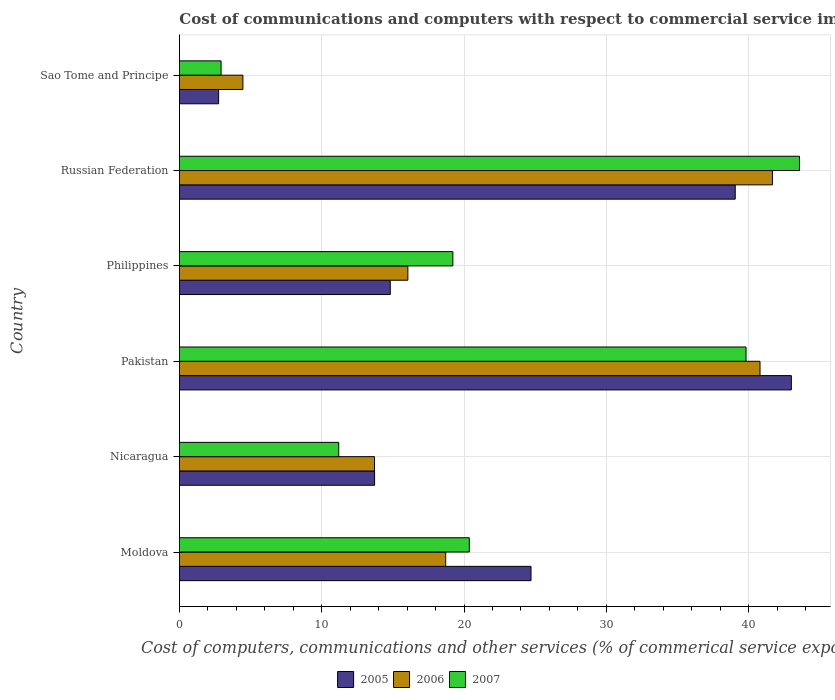How many different coloured bars are there?
Offer a very short reply. 3. Are the number of bars on each tick of the Y-axis equal?
Keep it short and to the point. Yes. How many bars are there on the 4th tick from the top?
Keep it short and to the point. 3. How many bars are there on the 2nd tick from the bottom?
Provide a short and direct response. 3. What is the label of the 3rd group of bars from the top?
Offer a terse response. Philippines. What is the cost of communications and computers in 2007 in Russian Federation?
Your answer should be very brief. 43.57. Across all countries, what is the maximum cost of communications and computers in 2007?
Give a very brief answer. 43.57. Across all countries, what is the minimum cost of communications and computers in 2005?
Provide a short and direct response. 2.76. In which country was the cost of communications and computers in 2005 minimum?
Your answer should be compact. Sao Tome and Principe. What is the total cost of communications and computers in 2006 in the graph?
Your response must be concise. 135.41. What is the difference between the cost of communications and computers in 2007 in Nicaragua and that in Russian Federation?
Your answer should be compact. -32.38. What is the difference between the cost of communications and computers in 2007 in Russian Federation and the cost of communications and computers in 2005 in Sao Tome and Principe?
Ensure brevity in your answer.  40.82. What is the average cost of communications and computers in 2005 per country?
Your response must be concise. 23.01. What is the difference between the cost of communications and computers in 2006 and cost of communications and computers in 2005 in Philippines?
Provide a short and direct response. 1.24. What is the ratio of the cost of communications and computers in 2005 in Moldova to that in Philippines?
Make the answer very short. 1.67. Is the difference between the cost of communications and computers in 2006 in Nicaragua and Pakistan greater than the difference between the cost of communications and computers in 2005 in Nicaragua and Pakistan?
Provide a succinct answer. Yes. What is the difference between the highest and the second highest cost of communications and computers in 2006?
Your answer should be compact. 0.87. What is the difference between the highest and the lowest cost of communications and computers in 2005?
Make the answer very short. 40.25. In how many countries, is the cost of communications and computers in 2005 greater than the average cost of communications and computers in 2005 taken over all countries?
Keep it short and to the point. 3. Is the sum of the cost of communications and computers in 2007 in Nicaragua and Philippines greater than the maximum cost of communications and computers in 2006 across all countries?
Your response must be concise. No. What does the 1st bar from the top in Philippines represents?
Provide a short and direct response. 2007. What does the 1st bar from the bottom in Pakistan represents?
Keep it short and to the point. 2005. How many bars are there?
Provide a succinct answer. 18. Are the values on the major ticks of X-axis written in scientific E-notation?
Provide a short and direct response. No. Does the graph contain any zero values?
Ensure brevity in your answer.  No. Does the graph contain grids?
Offer a terse response. Yes. Where does the legend appear in the graph?
Make the answer very short. Bottom center. What is the title of the graph?
Offer a terse response. Cost of communications and computers with respect to commercial service imports. What is the label or title of the X-axis?
Keep it short and to the point. Cost of computers, communications and other services (% of commerical service exports). What is the Cost of computers, communications and other services (% of commerical service exports) in 2005 in Moldova?
Keep it short and to the point. 24.71. What is the Cost of computers, communications and other services (% of commerical service exports) in 2006 in Moldova?
Your response must be concise. 18.71. What is the Cost of computers, communications and other services (% of commerical service exports) of 2007 in Moldova?
Make the answer very short. 20.37. What is the Cost of computers, communications and other services (% of commerical service exports) in 2005 in Nicaragua?
Provide a short and direct response. 13.72. What is the Cost of computers, communications and other services (% of commerical service exports) of 2006 in Nicaragua?
Your answer should be compact. 13.71. What is the Cost of computers, communications and other services (% of commerical service exports) in 2007 in Nicaragua?
Your answer should be compact. 11.2. What is the Cost of computers, communications and other services (% of commerical service exports) in 2005 in Pakistan?
Offer a very short reply. 43. What is the Cost of computers, communications and other services (% of commerical service exports) in 2006 in Pakistan?
Your response must be concise. 40.8. What is the Cost of computers, communications and other services (% of commerical service exports) in 2007 in Pakistan?
Keep it short and to the point. 39.82. What is the Cost of computers, communications and other services (% of commerical service exports) in 2005 in Philippines?
Offer a very short reply. 14.82. What is the Cost of computers, communications and other services (% of commerical service exports) of 2006 in Philippines?
Provide a succinct answer. 16.05. What is the Cost of computers, communications and other services (% of commerical service exports) in 2007 in Philippines?
Your answer should be very brief. 19.22. What is the Cost of computers, communications and other services (% of commerical service exports) of 2005 in Russian Federation?
Provide a short and direct response. 39.06. What is the Cost of computers, communications and other services (% of commerical service exports) in 2006 in Russian Federation?
Offer a very short reply. 41.67. What is the Cost of computers, communications and other services (% of commerical service exports) of 2007 in Russian Federation?
Provide a succinct answer. 43.57. What is the Cost of computers, communications and other services (% of commerical service exports) in 2005 in Sao Tome and Principe?
Make the answer very short. 2.76. What is the Cost of computers, communications and other services (% of commerical service exports) of 2006 in Sao Tome and Principe?
Your answer should be very brief. 4.46. What is the Cost of computers, communications and other services (% of commerical service exports) in 2007 in Sao Tome and Principe?
Offer a terse response. 2.93. Across all countries, what is the maximum Cost of computers, communications and other services (% of commerical service exports) in 2005?
Your answer should be very brief. 43. Across all countries, what is the maximum Cost of computers, communications and other services (% of commerical service exports) in 2006?
Give a very brief answer. 41.67. Across all countries, what is the maximum Cost of computers, communications and other services (% of commerical service exports) of 2007?
Give a very brief answer. 43.57. Across all countries, what is the minimum Cost of computers, communications and other services (% of commerical service exports) in 2005?
Make the answer very short. 2.76. Across all countries, what is the minimum Cost of computers, communications and other services (% of commerical service exports) of 2006?
Make the answer very short. 4.46. Across all countries, what is the minimum Cost of computers, communications and other services (% of commerical service exports) of 2007?
Your answer should be very brief. 2.93. What is the total Cost of computers, communications and other services (% of commerical service exports) in 2005 in the graph?
Offer a terse response. 138.06. What is the total Cost of computers, communications and other services (% of commerical service exports) in 2006 in the graph?
Give a very brief answer. 135.41. What is the total Cost of computers, communications and other services (% of commerical service exports) in 2007 in the graph?
Provide a succinct answer. 137.1. What is the difference between the Cost of computers, communications and other services (% of commerical service exports) in 2005 in Moldova and that in Nicaragua?
Offer a very short reply. 10.99. What is the difference between the Cost of computers, communications and other services (% of commerical service exports) in 2006 in Moldova and that in Nicaragua?
Your response must be concise. 5. What is the difference between the Cost of computers, communications and other services (% of commerical service exports) of 2007 in Moldova and that in Nicaragua?
Keep it short and to the point. 9.18. What is the difference between the Cost of computers, communications and other services (% of commerical service exports) of 2005 in Moldova and that in Pakistan?
Offer a very short reply. -18.29. What is the difference between the Cost of computers, communications and other services (% of commerical service exports) of 2006 in Moldova and that in Pakistan?
Offer a very short reply. -22.09. What is the difference between the Cost of computers, communications and other services (% of commerical service exports) of 2007 in Moldova and that in Pakistan?
Keep it short and to the point. -19.45. What is the difference between the Cost of computers, communications and other services (% of commerical service exports) of 2005 in Moldova and that in Philippines?
Make the answer very short. 9.89. What is the difference between the Cost of computers, communications and other services (% of commerical service exports) in 2006 in Moldova and that in Philippines?
Make the answer very short. 2.66. What is the difference between the Cost of computers, communications and other services (% of commerical service exports) in 2007 in Moldova and that in Philippines?
Ensure brevity in your answer.  1.15. What is the difference between the Cost of computers, communications and other services (% of commerical service exports) in 2005 in Moldova and that in Russian Federation?
Keep it short and to the point. -14.35. What is the difference between the Cost of computers, communications and other services (% of commerical service exports) in 2006 in Moldova and that in Russian Federation?
Keep it short and to the point. -22.96. What is the difference between the Cost of computers, communications and other services (% of commerical service exports) in 2007 in Moldova and that in Russian Federation?
Provide a short and direct response. -23.2. What is the difference between the Cost of computers, communications and other services (% of commerical service exports) in 2005 in Moldova and that in Sao Tome and Principe?
Offer a terse response. 21.95. What is the difference between the Cost of computers, communications and other services (% of commerical service exports) of 2006 in Moldova and that in Sao Tome and Principe?
Your response must be concise. 14.25. What is the difference between the Cost of computers, communications and other services (% of commerical service exports) in 2007 in Moldova and that in Sao Tome and Principe?
Your answer should be very brief. 17.44. What is the difference between the Cost of computers, communications and other services (% of commerical service exports) in 2005 in Nicaragua and that in Pakistan?
Offer a terse response. -29.29. What is the difference between the Cost of computers, communications and other services (% of commerical service exports) of 2006 in Nicaragua and that in Pakistan?
Your answer should be very brief. -27.09. What is the difference between the Cost of computers, communications and other services (% of commerical service exports) in 2007 in Nicaragua and that in Pakistan?
Ensure brevity in your answer.  -28.62. What is the difference between the Cost of computers, communications and other services (% of commerical service exports) in 2005 in Nicaragua and that in Philippines?
Provide a succinct answer. -1.1. What is the difference between the Cost of computers, communications and other services (% of commerical service exports) of 2006 in Nicaragua and that in Philippines?
Your answer should be compact. -2.34. What is the difference between the Cost of computers, communications and other services (% of commerical service exports) in 2007 in Nicaragua and that in Philippines?
Offer a terse response. -8.02. What is the difference between the Cost of computers, communications and other services (% of commerical service exports) in 2005 in Nicaragua and that in Russian Federation?
Provide a short and direct response. -25.34. What is the difference between the Cost of computers, communications and other services (% of commerical service exports) in 2006 in Nicaragua and that in Russian Federation?
Make the answer very short. -27.96. What is the difference between the Cost of computers, communications and other services (% of commerical service exports) in 2007 in Nicaragua and that in Russian Federation?
Ensure brevity in your answer.  -32.38. What is the difference between the Cost of computers, communications and other services (% of commerical service exports) in 2005 in Nicaragua and that in Sao Tome and Principe?
Your answer should be compact. 10.96. What is the difference between the Cost of computers, communications and other services (% of commerical service exports) in 2006 in Nicaragua and that in Sao Tome and Principe?
Give a very brief answer. 9.25. What is the difference between the Cost of computers, communications and other services (% of commerical service exports) in 2007 in Nicaragua and that in Sao Tome and Principe?
Give a very brief answer. 8.27. What is the difference between the Cost of computers, communications and other services (% of commerical service exports) of 2005 in Pakistan and that in Philippines?
Provide a short and direct response. 28.18. What is the difference between the Cost of computers, communications and other services (% of commerical service exports) in 2006 in Pakistan and that in Philippines?
Give a very brief answer. 24.75. What is the difference between the Cost of computers, communications and other services (% of commerical service exports) in 2007 in Pakistan and that in Philippines?
Keep it short and to the point. 20.6. What is the difference between the Cost of computers, communications and other services (% of commerical service exports) in 2005 in Pakistan and that in Russian Federation?
Ensure brevity in your answer.  3.94. What is the difference between the Cost of computers, communications and other services (% of commerical service exports) in 2006 in Pakistan and that in Russian Federation?
Your answer should be very brief. -0.87. What is the difference between the Cost of computers, communications and other services (% of commerical service exports) of 2007 in Pakistan and that in Russian Federation?
Your answer should be compact. -3.76. What is the difference between the Cost of computers, communications and other services (% of commerical service exports) of 2005 in Pakistan and that in Sao Tome and Principe?
Make the answer very short. 40.25. What is the difference between the Cost of computers, communications and other services (% of commerical service exports) of 2006 in Pakistan and that in Sao Tome and Principe?
Your answer should be compact. 36.34. What is the difference between the Cost of computers, communications and other services (% of commerical service exports) in 2007 in Pakistan and that in Sao Tome and Principe?
Your answer should be very brief. 36.89. What is the difference between the Cost of computers, communications and other services (% of commerical service exports) in 2005 in Philippines and that in Russian Federation?
Provide a succinct answer. -24.24. What is the difference between the Cost of computers, communications and other services (% of commerical service exports) in 2006 in Philippines and that in Russian Federation?
Give a very brief answer. -25.62. What is the difference between the Cost of computers, communications and other services (% of commerical service exports) of 2007 in Philippines and that in Russian Federation?
Offer a terse response. -24.36. What is the difference between the Cost of computers, communications and other services (% of commerical service exports) of 2005 in Philippines and that in Sao Tome and Principe?
Your answer should be very brief. 12.06. What is the difference between the Cost of computers, communications and other services (% of commerical service exports) of 2006 in Philippines and that in Sao Tome and Principe?
Ensure brevity in your answer.  11.59. What is the difference between the Cost of computers, communications and other services (% of commerical service exports) of 2007 in Philippines and that in Sao Tome and Principe?
Your answer should be compact. 16.29. What is the difference between the Cost of computers, communications and other services (% of commerical service exports) of 2005 in Russian Federation and that in Sao Tome and Principe?
Your answer should be very brief. 36.3. What is the difference between the Cost of computers, communications and other services (% of commerical service exports) of 2006 in Russian Federation and that in Sao Tome and Principe?
Ensure brevity in your answer.  37.21. What is the difference between the Cost of computers, communications and other services (% of commerical service exports) of 2007 in Russian Federation and that in Sao Tome and Principe?
Ensure brevity in your answer.  40.65. What is the difference between the Cost of computers, communications and other services (% of commerical service exports) in 2005 in Moldova and the Cost of computers, communications and other services (% of commerical service exports) in 2006 in Nicaragua?
Your response must be concise. 11. What is the difference between the Cost of computers, communications and other services (% of commerical service exports) in 2005 in Moldova and the Cost of computers, communications and other services (% of commerical service exports) in 2007 in Nicaragua?
Provide a short and direct response. 13.51. What is the difference between the Cost of computers, communications and other services (% of commerical service exports) in 2006 in Moldova and the Cost of computers, communications and other services (% of commerical service exports) in 2007 in Nicaragua?
Your answer should be very brief. 7.52. What is the difference between the Cost of computers, communications and other services (% of commerical service exports) of 2005 in Moldova and the Cost of computers, communications and other services (% of commerical service exports) of 2006 in Pakistan?
Ensure brevity in your answer.  -16.09. What is the difference between the Cost of computers, communications and other services (% of commerical service exports) in 2005 in Moldova and the Cost of computers, communications and other services (% of commerical service exports) in 2007 in Pakistan?
Offer a very short reply. -15.11. What is the difference between the Cost of computers, communications and other services (% of commerical service exports) in 2006 in Moldova and the Cost of computers, communications and other services (% of commerical service exports) in 2007 in Pakistan?
Provide a succinct answer. -21.11. What is the difference between the Cost of computers, communications and other services (% of commerical service exports) in 2005 in Moldova and the Cost of computers, communications and other services (% of commerical service exports) in 2006 in Philippines?
Provide a short and direct response. 8.65. What is the difference between the Cost of computers, communications and other services (% of commerical service exports) in 2005 in Moldova and the Cost of computers, communications and other services (% of commerical service exports) in 2007 in Philippines?
Offer a terse response. 5.49. What is the difference between the Cost of computers, communications and other services (% of commerical service exports) in 2006 in Moldova and the Cost of computers, communications and other services (% of commerical service exports) in 2007 in Philippines?
Give a very brief answer. -0.5. What is the difference between the Cost of computers, communications and other services (% of commerical service exports) of 2005 in Moldova and the Cost of computers, communications and other services (% of commerical service exports) of 2006 in Russian Federation?
Your response must be concise. -16.96. What is the difference between the Cost of computers, communications and other services (% of commerical service exports) of 2005 in Moldova and the Cost of computers, communications and other services (% of commerical service exports) of 2007 in Russian Federation?
Your answer should be very brief. -18.87. What is the difference between the Cost of computers, communications and other services (% of commerical service exports) in 2006 in Moldova and the Cost of computers, communications and other services (% of commerical service exports) in 2007 in Russian Federation?
Provide a short and direct response. -24.86. What is the difference between the Cost of computers, communications and other services (% of commerical service exports) in 2005 in Moldova and the Cost of computers, communications and other services (% of commerical service exports) in 2006 in Sao Tome and Principe?
Keep it short and to the point. 20.25. What is the difference between the Cost of computers, communications and other services (% of commerical service exports) of 2005 in Moldova and the Cost of computers, communications and other services (% of commerical service exports) of 2007 in Sao Tome and Principe?
Ensure brevity in your answer.  21.78. What is the difference between the Cost of computers, communications and other services (% of commerical service exports) of 2006 in Moldova and the Cost of computers, communications and other services (% of commerical service exports) of 2007 in Sao Tome and Principe?
Make the answer very short. 15.78. What is the difference between the Cost of computers, communications and other services (% of commerical service exports) of 2005 in Nicaragua and the Cost of computers, communications and other services (% of commerical service exports) of 2006 in Pakistan?
Make the answer very short. -27.09. What is the difference between the Cost of computers, communications and other services (% of commerical service exports) in 2005 in Nicaragua and the Cost of computers, communications and other services (% of commerical service exports) in 2007 in Pakistan?
Offer a very short reply. -26.1. What is the difference between the Cost of computers, communications and other services (% of commerical service exports) of 2006 in Nicaragua and the Cost of computers, communications and other services (% of commerical service exports) of 2007 in Pakistan?
Your answer should be compact. -26.11. What is the difference between the Cost of computers, communications and other services (% of commerical service exports) of 2005 in Nicaragua and the Cost of computers, communications and other services (% of commerical service exports) of 2006 in Philippines?
Your response must be concise. -2.34. What is the difference between the Cost of computers, communications and other services (% of commerical service exports) in 2005 in Nicaragua and the Cost of computers, communications and other services (% of commerical service exports) in 2007 in Philippines?
Offer a terse response. -5.5. What is the difference between the Cost of computers, communications and other services (% of commerical service exports) in 2006 in Nicaragua and the Cost of computers, communications and other services (% of commerical service exports) in 2007 in Philippines?
Give a very brief answer. -5.51. What is the difference between the Cost of computers, communications and other services (% of commerical service exports) of 2005 in Nicaragua and the Cost of computers, communications and other services (% of commerical service exports) of 2006 in Russian Federation?
Offer a terse response. -27.96. What is the difference between the Cost of computers, communications and other services (% of commerical service exports) of 2005 in Nicaragua and the Cost of computers, communications and other services (% of commerical service exports) of 2007 in Russian Federation?
Offer a very short reply. -29.86. What is the difference between the Cost of computers, communications and other services (% of commerical service exports) in 2006 in Nicaragua and the Cost of computers, communications and other services (% of commerical service exports) in 2007 in Russian Federation?
Give a very brief answer. -29.86. What is the difference between the Cost of computers, communications and other services (% of commerical service exports) of 2005 in Nicaragua and the Cost of computers, communications and other services (% of commerical service exports) of 2006 in Sao Tome and Principe?
Provide a succinct answer. 9.25. What is the difference between the Cost of computers, communications and other services (% of commerical service exports) of 2005 in Nicaragua and the Cost of computers, communications and other services (% of commerical service exports) of 2007 in Sao Tome and Principe?
Your response must be concise. 10.79. What is the difference between the Cost of computers, communications and other services (% of commerical service exports) of 2006 in Nicaragua and the Cost of computers, communications and other services (% of commerical service exports) of 2007 in Sao Tome and Principe?
Make the answer very short. 10.78. What is the difference between the Cost of computers, communications and other services (% of commerical service exports) in 2005 in Pakistan and the Cost of computers, communications and other services (% of commerical service exports) in 2006 in Philippines?
Give a very brief answer. 26.95. What is the difference between the Cost of computers, communications and other services (% of commerical service exports) of 2005 in Pakistan and the Cost of computers, communications and other services (% of commerical service exports) of 2007 in Philippines?
Your answer should be very brief. 23.79. What is the difference between the Cost of computers, communications and other services (% of commerical service exports) of 2006 in Pakistan and the Cost of computers, communications and other services (% of commerical service exports) of 2007 in Philippines?
Ensure brevity in your answer.  21.58. What is the difference between the Cost of computers, communications and other services (% of commerical service exports) of 2005 in Pakistan and the Cost of computers, communications and other services (% of commerical service exports) of 2006 in Russian Federation?
Give a very brief answer. 1.33. What is the difference between the Cost of computers, communications and other services (% of commerical service exports) of 2005 in Pakistan and the Cost of computers, communications and other services (% of commerical service exports) of 2007 in Russian Federation?
Your answer should be very brief. -0.57. What is the difference between the Cost of computers, communications and other services (% of commerical service exports) in 2006 in Pakistan and the Cost of computers, communications and other services (% of commerical service exports) in 2007 in Russian Federation?
Offer a terse response. -2.77. What is the difference between the Cost of computers, communications and other services (% of commerical service exports) of 2005 in Pakistan and the Cost of computers, communications and other services (% of commerical service exports) of 2006 in Sao Tome and Principe?
Make the answer very short. 38.54. What is the difference between the Cost of computers, communications and other services (% of commerical service exports) in 2005 in Pakistan and the Cost of computers, communications and other services (% of commerical service exports) in 2007 in Sao Tome and Principe?
Provide a short and direct response. 40.07. What is the difference between the Cost of computers, communications and other services (% of commerical service exports) of 2006 in Pakistan and the Cost of computers, communications and other services (% of commerical service exports) of 2007 in Sao Tome and Principe?
Your answer should be compact. 37.87. What is the difference between the Cost of computers, communications and other services (% of commerical service exports) of 2005 in Philippines and the Cost of computers, communications and other services (% of commerical service exports) of 2006 in Russian Federation?
Give a very brief answer. -26.85. What is the difference between the Cost of computers, communications and other services (% of commerical service exports) in 2005 in Philippines and the Cost of computers, communications and other services (% of commerical service exports) in 2007 in Russian Federation?
Provide a short and direct response. -28.76. What is the difference between the Cost of computers, communications and other services (% of commerical service exports) of 2006 in Philippines and the Cost of computers, communications and other services (% of commerical service exports) of 2007 in Russian Federation?
Your response must be concise. -27.52. What is the difference between the Cost of computers, communications and other services (% of commerical service exports) in 2005 in Philippines and the Cost of computers, communications and other services (% of commerical service exports) in 2006 in Sao Tome and Principe?
Offer a terse response. 10.36. What is the difference between the Cost of computers, communications and other services (% of commerical service exports) of 2005 in Philippines and the Cost of computers, communications and other services (% of commerical service exports) of 2007 in Sao Tome and Principe?
Keep it short and to the point. 11.89. What is the difference between the Cost of computers, communications and other services (% of commerical service exports) in 2006 in Philippines and the Cost of computers, communications and other services (% of commerical service exports) in 2007 in Sao Tome and Principe?
Give a very brief answer. 13.13. What is the difference between the Cost of computers, communications and other services (% of commerical service exports) in 2005 in Russian Federation and the Cost of computers, communications and other services (% of commerical service exports) in 2006 in Sao Tome and Principe?
Offer a terse response. 34.6. What is the difference between the Cost of computers, communications and other services (% of commerical service exports) in 2005 in Russian Federation and the Cost of computers, communications and other services (% of commerical service exports) in 2007 in Sao Tome and Principe?
Your answer should be very brief. 36.13. What is the difference between the Cost of computers, communications and other services (% of commerical service exports) of 2006 in Russian Federation and the Cost of computers, communications and other services (% of commerical service exports) of 2007 in Sao Tome and Principe?
Your response must be concise. 38.74. What is the average Cost of computers, communications and other services (% of commerical service exports) of 2005 per country?
Provide a succinct answer. 23.01. What is the average Cost of computers, communications and other services (% of commerical service exports) in 2006 per country?
Give a very brief answer. 22.57. What is the average Cost of computers, communications and other services (% of commerical service exports) in 2007 per country?
Offer a very short reply. 22.85. What is the difference between the Cost of computers, communications and other services (% of commerical service exports) of 2005 and Cost of computers, communications and other services (% of commerical service exports) of 2006 in Moldova?
Offer a terse response. 6. What is the difference between the Cost of computers, communications and other services (% of commerical service exports) of 2005 and Cost of computers, communications and other services (% of commerical service exports) of 2007 in Moldova?
Offer a very short reply. 4.34. What is the difference between the Cost of computers, communications and other services (% of commerical service exports) in 2006 and Cost of computers, communications and other services (% of commerical service exports) in 2007 in Moldova?
Your response must be concise. -1.66. What is the difference between the Cost of computers, communications and other services (% of commerical service exports) in 2005 and Cost of computers, communications and other services (% of commerical service exports) in 2006 in Nicaragua?
Provide a short and direct response. 0.01. What is the difference between the Cost of computers, communications and other services (% of commerical service exports) in 2005 and Cost of computers, communications and other services (% of commerical service exports) in 2007 in Nicaragua?
Make the answer very short. 2.52. What is the difference between the Cost of computers, communications and other services (% of commerical service exports) in 2006 and Cost of computers, communications and other services (% of commerical service exports) in 2007 in Nicaragua?
Provide a short and direct response. 2.52. What is the difference between the Cost of computers, communications and other services (% of commerical service exports) in 2005 and Cost of computers, communications and other services (% of commerical service exports) in 2006 in Pakistan?
Make the answer very short. 2.2. What is the difference between the Cost of computers, communications and other services (% of commerical service exports) in 2005 and Cost of computers, communications and other services (% of commerical service exports) in 2007 in Pakistan?
Keep it short and to the point. 3.18. What is the difference between the Cost of computers, communications and other services (% of commerical service exports) in 2006 and Cost of computers, communications and other services (% of commerical service exports) in 2007 in Pakistan?
Offer a terse response. 0.98. What is the difference between the Cost of computers, communications and other services (% of commerical service exports) of 2005 and Cost of computers, communications and other services (% of commerical service exports) of 2006 in Philippines?
Your answer should be compact. -1.24. What is the difference between the Cost of computers, communications and other services (% of commerical service exports) of 2005 and Cost of computers, communications and other services (% of commerical service exports) of 2007 in Philippines?
Provide a succinct answer. -4.4. What is the difference between the Cost of computers, communications and other services (% of commerical service exports) in 2006 and Cost of computers, communications and other services (% of commerical service exports) in 2007 in Philippines?
Offer a terse response. -3.16. What is the difference between the Cost of computers, communications and other services (% of commerical service exports) of 2005 and Cost of computers, communications and other services (% of commerical service exports) of 2006 in Russian Federation?
Offer a terse response. -2.61. What is the difference between the Cost of computers, communications and other services (% of commerical service exports) in 2005 and Cost of computers, communications and other services (% of commerical service exports) in 2007 in Russian Federation?
Provide a short and direct response. -4.52. What is the difference between the Cost of computers, communications and other services (% of commerical service exports) in 2006 and Cost of computers, communications and other services (% of commerical service exports) in 2007 in Russian Federation?
Provide a short and direct response. -1.9. What is the difference between the Cost of computers, communications and other services (% of commerical service exports) of 2005 and Cost of computers, communications and other services (% of commerical service exports) of 2006 in Sao Tome and Principe?
Offer a very short reply. -1.71. What is the difference between the Cost of computers, communications and other services (% of commerical service exports) of 2005 and Cost of computers, communications and other services (% of commerical service exports) of 2007 in Sao Tome and Principe?
Your response must be concise. -0.17. What is the difference between the Cost of computers, communications and other services (% of commerical service exports) of 2006 and Cost of computers, communications and other services (% of commerical service exports) of 2007 in Sao Tome and Principe?
Ensure brevity in your answer.  1.53. What is the ratio of the Cost of computers, communications and other services (% of commerical service exports) of 2005 in Moldova to that in Nicaragua?
Your answer should be compact. 1.8. What is the ratio of the Cost of computers, communications and other services (% of commerical service exports) in 2006 in Moldova to that in Nicaragua?
Provide a short and direct response. 1.36. What is the ratio of the Cost of computers, communications and other services (% of commerical service exports) of 2007 in Moldova to that in Nicaragua?
Offer a very short reply. 1.82. What is the ratio of the Cost of computers, communications and other services (% of commerical service exports) of 2005 in Moldova to that in Pakistan?
Keep it short and to the point. 0.57. What is the ratio of the Cost of computers, communications and other services (% of commerical service exports) of 2006 in Moldova to that in Pakistan?
Your response must be concise. 0.46. What is the ratio of the Cost of computers, communications and other services (% of commerical service exports) of 2007 in Moldova to that in Pakistan?
Keep it short and to the point. 0.51. What is the ratio of the Cost of computers, communications and other services (% of commerical service exports) of 2005 in Moldova to that in Philippines?
Your answer should be very brief. 1.67. What is the ratio of the Cost of computers, communications and other services (% of commerical service exports) of 2006 in Moldova to that in Philippines?
Your answer should be very brief. 1.17. What is the ratio of the Cost of computers, communications and other services (% of commerical service exports) of 2007 in Moldova to that in Philippines?
Ensure brevity in your answer.  1.06. What is the ratio of the Cost of computers, communications and other services (% of commerical service exports) of 2005 in Moldova to that in Russian Federation?
Ensure brevity in your answer.  0.63. What is the ratio of the Cost of computers, communications and other services (% of commerical service exports) in 2006 in Moldova to that in Russian Federation?
Offer a very short reply. 0.45. What is the ratio of the Cost of computers, communications and other services (% of commerical service exports) of 2007 in Moldova to that in Russian Federation?
Provide a short and direct response. 0.47. What is the ratio of the Cost of computers, communications and other services (% of commerical service exports) in 2005 in Moldova to that in Sao Tome and Principe?
Your answer should be very brief. 8.97. What is the ratio of the Cost of computers, communications and other services (% of commerical service exports) of 2006 in Moldova to that in Sao Tome and Principe?
Offer a terse response. 4.19. What is the ratio of the Cost of computers, communications and other services (% of commerical service exports) of 2007 in Moldova to that in Sao Tome and Principe?
Your response must be concise. 6.96. What is the ratio of the Cost of computers, communications and other services (% of commerical service exports) of 2005 in Nicaragua to that in Pakistan?
Your response must be concise. 0.32. What is the ratio of the Cost of computers, communications and other services (% of commerical service exports) in 2006 in Nicaragua to that in Pakistan?
Offer a terse response. 0.34. What is the ratio of the Cost of computers, communications and other services (% of commerical service exports) in 2007 in Nicaragua to that in Pakistan?
Keep it short and to the point. 0.28. What is the ratio of the Cost of computers, communications and other services (% of commerical service exports) in 2005 in Nicaragua to that in Philippines?
Keep it short and to the point. 0.93. What is the ratio of the Cost of computers, communications and other services (% of commerical service exports) of 2006 in Nicaragua to that in Philippines?
Provide a succinct answer. 0.85. What is the ratio of the Cost of computers, communications and other services (% of commerical service exports) in 2007 in Nicaragua to that in Philippines?
Offer a very short reply. 0.58. What is the ratio of the Cost of computers, communications and other services (% of commerical service exports) of 2005 in Nicaragua to that in Russian Federation?
Ensure brevity in your answer.  0.35. What is the ratio of the Cost of computers, communications and other services (% of commerical service exports) in 2006 in Nicaragua to that in Russian Federation?
Ensure brevity in your answer.  0.33. What is the ratio of the Cost of computers, communications and other services (% of commerical service exports) of 2007 in Nicaragua to that in Russian Federation?
Your answer should be very brief. 0.26. What is the ratio of the Cost of computers, communications and other services (% of commerical service exports) in 2005 in Nicaragua to that in Sao Tome and Principe?
Provide a succinct answer. 4.98. What is the ratio of the Cost of computers, communications and other services (% of commerical service exports) in 2006 in Nicaragua to that in Sao Tome and Principe?
Your answer should be compact. 3.07. What is the ratio of the Cost of computers, communications and other services (% of commerical service exports) of 2007 in Nicaragua to that in Sao Tome and Principe?
Offer a terse response. 3.82. What is the ratio of the Cost of computers, communications and other services (% of commerical service exports) in 2005 in Pakistan to that in Philippines?
Your answer should be compact. 2.9. What is the ratio of the Cost of computers, communications and other services (% of commerical service exports) of 2006 in Pakistan to that in Philippines?
Make the answer very short. 2.54. What is the ratio of the Cost of computers, communications and other services (% of commerical service exports) of 2007 in Pakistan to that in Philippines?
Make the answer very short. 2.07. What is the ratio of the Cost of computers, communications and other services (% of commerical service exports) in 2005 in Pakistan to that in Russian Federation?
Make the answer very short. 1.1. What is the ratio of the Cost of computers, communications and other services (% of commerical service exports) of 2006 in Pakistan to that in Russian Federation?
Ensure brevity in your answer.  0.98. What is the ratio of the Cost of computers, communications and other services (% of commerical service exports) of 2007 in Pakistan to that in Russian Federation?
Provide a succinct answer. 0.91. What is the ratio of the Cost of computers, communications and other services (% of commerical service exports) of 2005 in Pakistan to that in Sao Tome and Principe?
Give a very brief answer. 15.61. What is the ratio of the Cost of computers, communications and other services (% of commerical service exports) of 2006 in Pakistan to that in Sao Tome and Principe?
Give a very brief answer. 9.15. What is the ratio of the Cost of computers, communications and other services (% of commerical service exports) in 2007 in Pakistan to that in Sao Tome and Principe?
Offer a terse response. 13.6. What is the ratio of the Cost of computers, communications and other services (% of commerical service exports) of 2005 in Philippines to that in Russian Federation?
Your answer should be very brief. 0.38. What is the ratio of the Cost of computers, communications and other services (% of commerical service exports) in 2006 in Philippines to that in Russian Federation?
Keep it short and to the point. 0.39. What is the ratio of the Cost of computers, communications and other services (% of commerical service exports) in 2007 in Philippines to that in Russian Federation?
Your response must be concise. 0.44. What is the ratio of the Cost of computers, communications and other services (% of commerical service exports) in 2005 in Philippines to that in Sao Tome and Principe?
Give a very brief answer. 5.38. What is the ratio of the Cost of computers, communications and other services (% of commerical service exports) in 2006 in Philippines to that in Sao Tome and Principe?
Provide a succinct answer. 3.6. What is the ratio of the Cost of computers, communications and other services (% of commerical service exports) in 2007 in Philippines to that in Sao Tome and Principe?
Offer a very short reply. 6.56. What is the ratio of the Cost of computers, communications and other services (% of commerical service exports) of 2005 in Russian Federation to that in Sao Tome and Principe?
Your answer should be very brief. 14.18. What is the ratio of the Cost of computers, communications and other services (% of commerical service exports) in 2006 in Russian Federation to that in Sao Tome and Principe?
Ensure brevity in your answer.  9.34. What is the ratio of the Cost of computers, communications and other services (% of commerical service exports) of 2007 in Russian Federation to that in Sao Tome and Principe?
Make the answer very short. 14.88. What is the difference between the highest and the second highest Cost of computers, communications and other services (% of commerical service exports) in 2005?
Ensure brevity in your answer.  3.94. What is the difference between the highest and the second highest Cost of computers, communications and other services (% of commerical service exports) in 2006?
Offer a very short reply. 0.87. What is the difference between the highest and the second highest Cost of computers, communications and other services (% of commerical service exports) of 2007?
Ensure brevity in your answer.  3.76. What is the difference between the highest and the lowest Cost of computers, communications and other services (% of commerical service exports) of 2005?
Provide a short and direct response. 40.25. What is the difference between the highest and the lowest Cost of computers, communications and other services (% of commerical service exports) in 2006?
Give a very brief answer. 37.21. What is the difference between the highest and the lowest Cost of computers, communications and other services (% of commerical service exports) of 2007?
Make the answer very short. 40.65. 